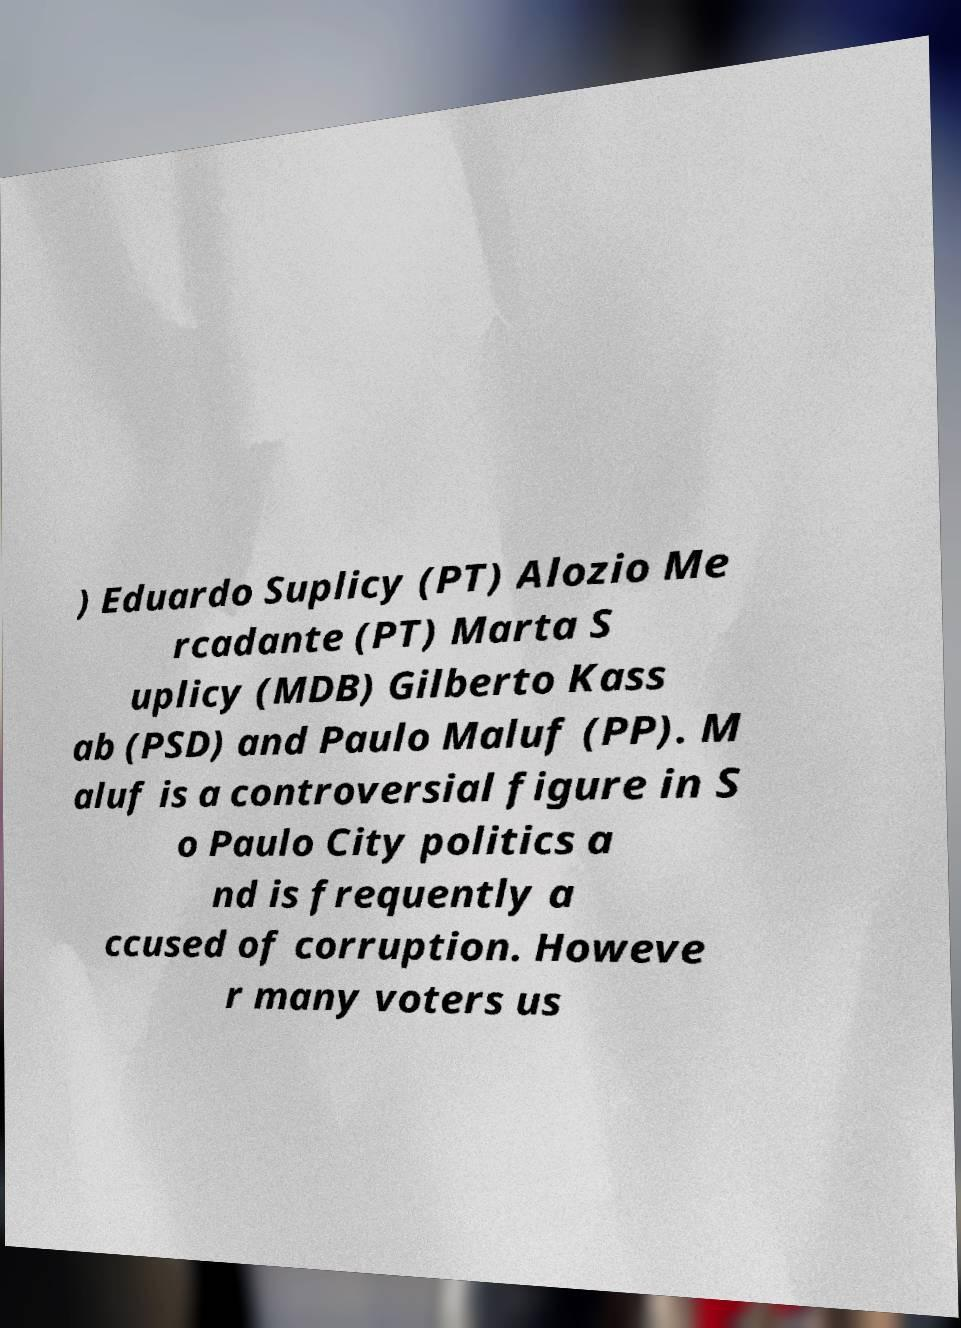Can you accurately transcribe the text from the provided image for me? ) Eduardo Suplicy (PT) Alozio Me rcadante (PT) Marta S uplicy (MDB) Gilberto Kass ab (PSD) and Paulo Maluf (PP). M aluf is a controversial figure in S o Paulo City politics a nd is frequently a ccused of corruption. Howeve r many voters us 